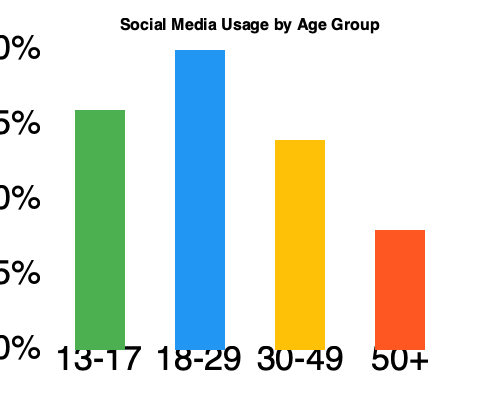Based on the bar graph showing social media usage across different age groups, which sociological phenomenon is most clearly illustrated, and how might this impact intergenerational communication and social cohesion? To answer this question, we need to analyze the data presented in the graph and consider its sociological implications:

1. Observe the trend: The graph shows a clear downward trend in social media usage as age increases.

2. Identify the phenomenon: This trend illustrates the concept of a "digital divide" based on age, also known as the "generational digital divide."

3. Analyze the data:
   - 13-17 age group: High usage (around 80%)
   - 18-29 age group: Highest usage (100%)
   - 30-49 age group: Moderate usage (about 70%)
   - 50+ age group: Lowest usage (approximately 40%)

4. Consider the implications:
   a) Intergenerational communication:
      - Younger generations may rely more on social media for communication.
      - Older generations might prefer traditional communication methods.
      - This difference could lead to communication gaps between age groups.

   b) Social cohesion:
      - Different levels of social media engagement may create separate "digital spheres" for different age groups.
      - This separation could potentially reinforce age-based social segregation.
      - It may also impact how different generations access information and form social networks.

5. Sociological perspective:
   - This phenomenon reflects how technology adoption varies across different cohorts.
   - It highlights the need to consider age as a factor in studies of digital literacy and online behavior.
   - The data suggests potential areas for further research on bridging the generational gap in digital spaces.
Answer: Generational digital divide; potential communication gaps and age-based digital segregation. 